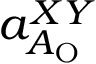Convert formula to latex. <formula><loc_0><loc_0><loc_500><loc_500>a _ { A _ { O } } ^ { X Y }</formula> 